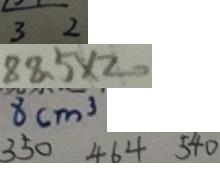Convert formula to latex. <formula><loc_0><loc_0><loc_500><loc_500>3 2 
 8 8 . 5 \times 2 0 
 8 c m ^ { 3 } 
 3 5 0 4 6 4 5 4 0</formula> 